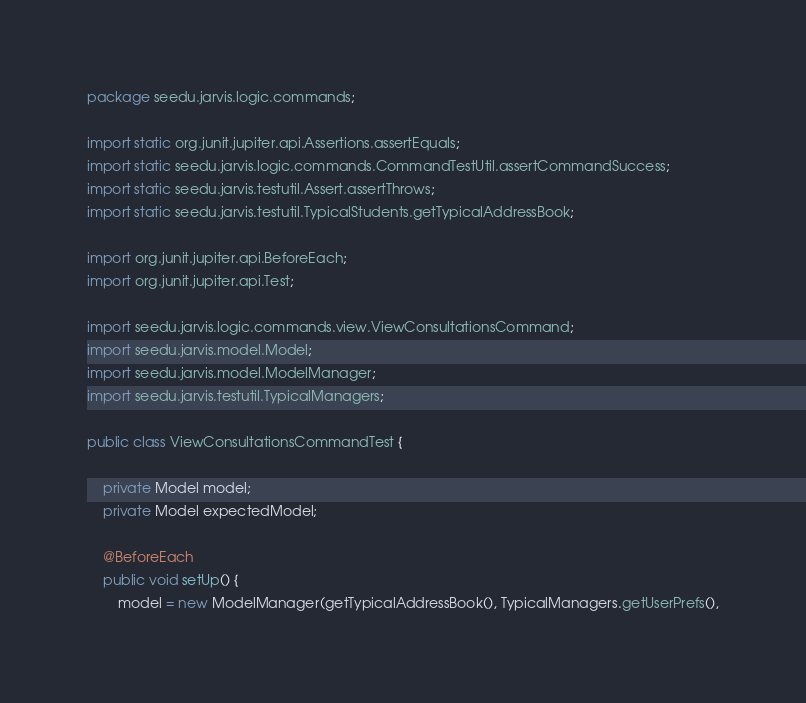Convert code to text. <code><loc_0><loc_0><loc_500><loc_500><_Java_>package seedu.jarvis.logic.commands;

import static org.junit.jupiter.api.Assertions.assertEquals;
import static seedu.jarvis.logic.commands.CommandTestUtil.assertCommandSuccess;
import static seedu.jarvis.testutil.Assert.assertThrows;
import static seedu.jarvis.testutil.TypicalStudents.getTypicalAddressBook;

import org.junit.jupiter.api.BeforeEach;
import org.junit.jupiter.api.Test;

import seedu.jarvis.logic.commands.view.ViewConsultationsCommand;
import seedu.jarvis.model.Model;
import seedu.jarvis.model.ModelManager;
import seedu.jarvis.testutil.TypicalManagers;

public class ViewConsultationsCommandTest {

    private Model model;
    private Model expectedModel;

    @BeforeEach
    public void setUp() {
        model = new ModelManager(getTypicalAddressBook(), TypicalManagers.getUserPrefs(),</code> 